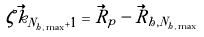<formula> <loc_0><loc_0><loc_500><loc_500>\zeta \vec { k } _ { N _ { h , \max } + 1 } & = \vec { R } _ { p } - \vec { R } _ { h , N _ { h , \max } }</formula> 